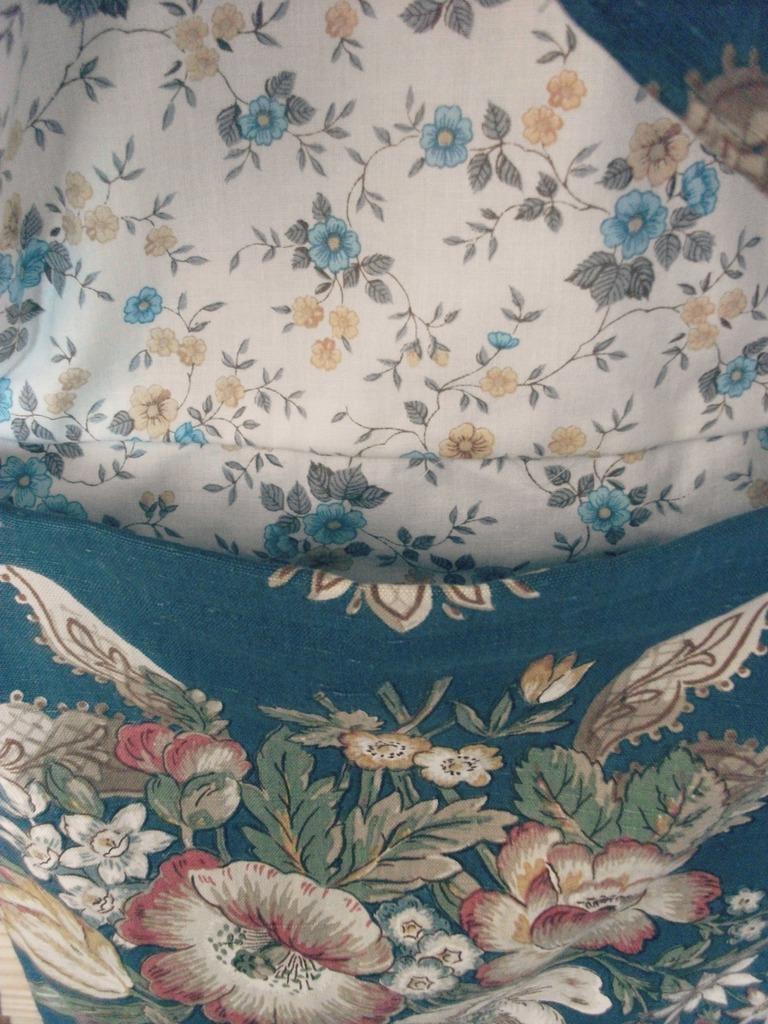How would you summarize this image in a sentence or two? In this picture we can observe a cloth with two different colors. One of the colors was white and there are some flowers printed on this cloth and the other color was blue and we can observe some flowers on this cloth. 